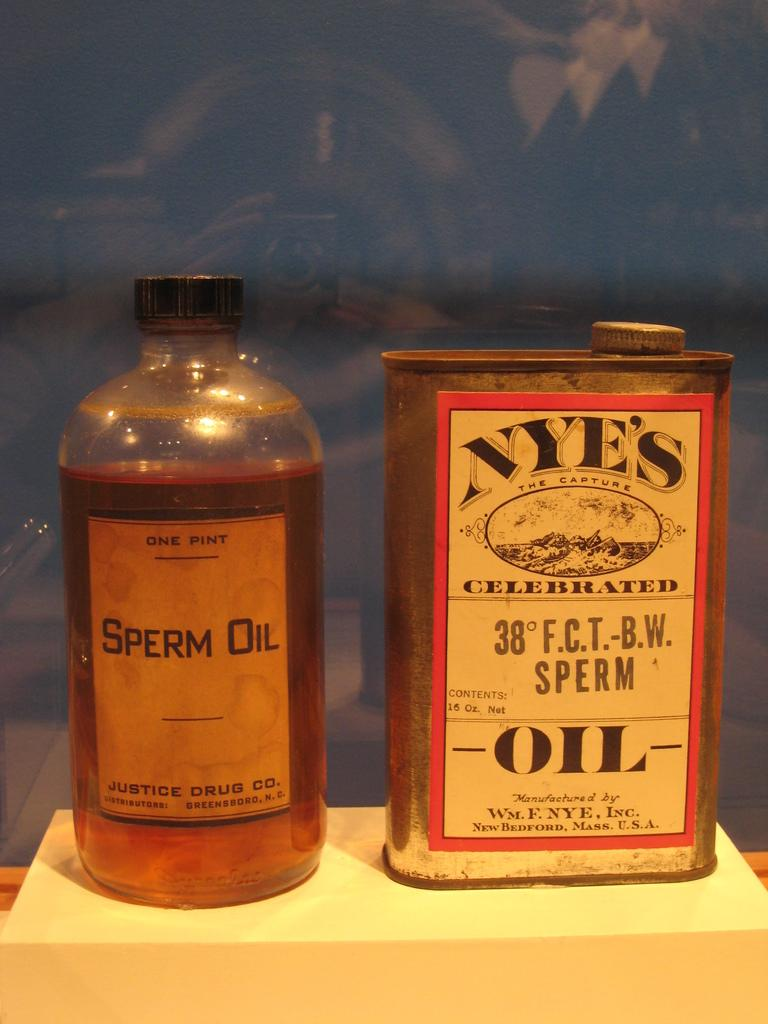<image>
Share a concise interpretation of the image provided. A bottle of sperm oil sits next to a metal can of oil. 